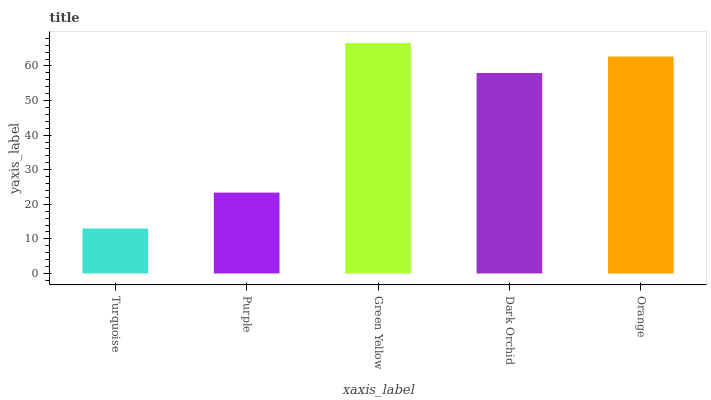Is Turquoise the minimum?
Answer yes or no. Yes. Is Green Yellow the maximum?
Answer yes or no. Yes. Is Purple the minimum?
Answer yes or no. No. Is Purple the maximum?
Answer yes or no. No. Is Purple greater than Turquoise?
Answer yes or no. Yes. Is Turquoise less than Purple?
Answer yes or no. Yes. Is Turquoise greater than Purple?
Answer yes or no. No. Is Purple less than Turquoise?
Answer yes or no. No. Is Dark Orchid the high median?
Answer yes or no. Yes. Is Dark Orchid the low median?
Answer yes or no. Yes. Is Green Yellow the high median?
Answer yes or no. No. Is Orange the low median?
Answer yes or no. No. 